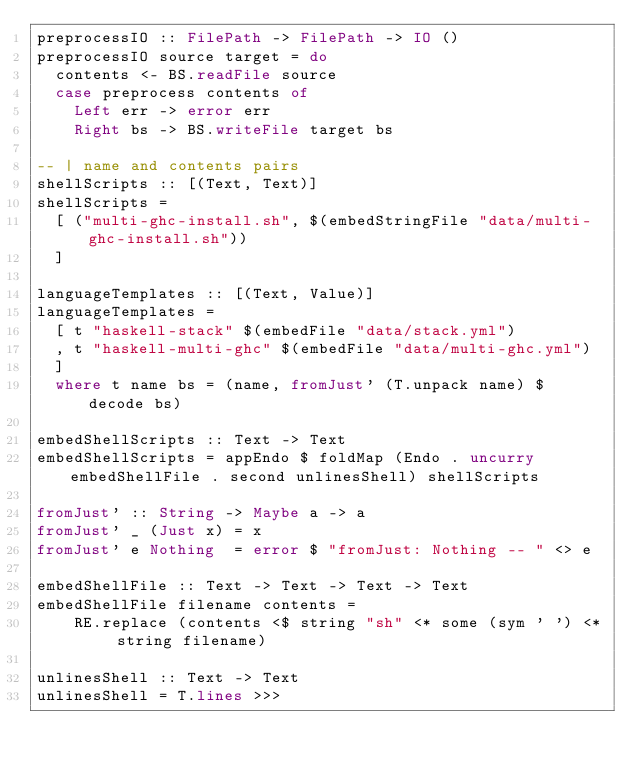Convert code to text. <code><loc_0><loc_0><loc_500><loc_500><_Haskell_>preprocessIO :: FilePath -> FilePath -> IO ()
preprocessIO source target = do
  contents <- BS.readFile source
  case preprocess contents of
    Left err -> error err
    Right bs -> BS.writeFile target bs

-- | name and contents pairs
shellScripts :: [(Text, Text)]
shellScripts =
  [ ("multi-ghc-install.sh", $(embedStringFile "data/multi-ghc-install.sh"))
  ]

languageTemplates :: [(Text, Value)]
languageTemplates =
  [ t "haskell-stack" $(embedFile "data/stack.yml")
  , t "haskell-multi-ghc" $(embedFile "data/multi-ghc.yml")
  ]
  where t name bs = (name, fromJust' (T.unpack name) $ decode bs)

embedShellScripts :: Text -> Text
embedShellScripts = appEndo $ foldMap (Endo . uncurry embedShellFile . second unlinesShell) shellScripts

fromJust' :: String -> Maybe a -> a
fromJust' _ (Just x) = x
fromJust' e Nothing  = error $ "fromJust: Nothing -- " <> e

embedShellFile :: Text -> Text -> Text -> Text
embedShellFile filename contents =
    RE.replace (contents <$ string "sh" <* some (sym ' ') <* string filename)

unlinesShell :: Text -> Text
unlinesShell = T.lines >>></code> 